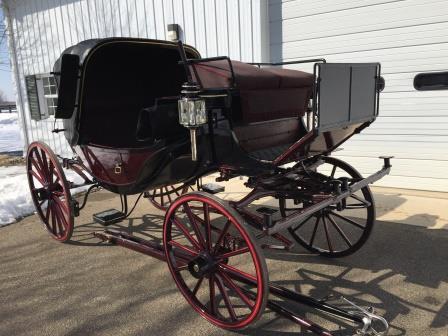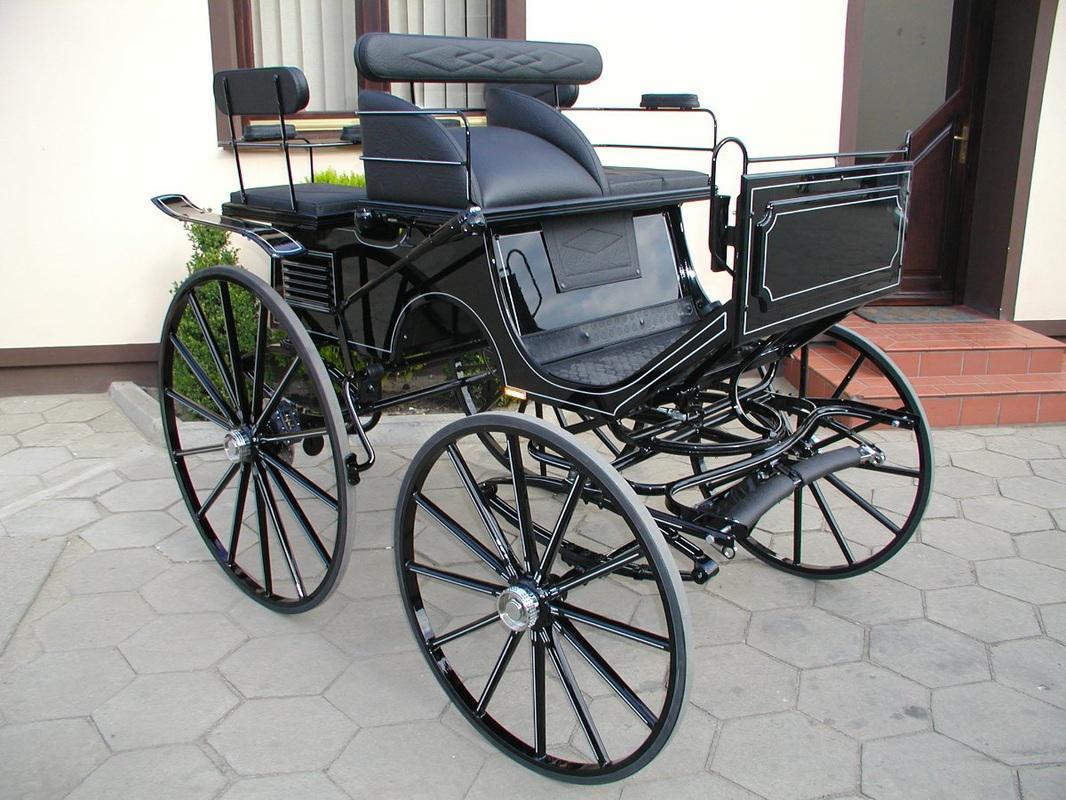The first image is the image on the left, the second image is the image on the right. Considering the images on both sides, is "At least one cart is facing toward the right." valid? Answer yes or no. Yes. 